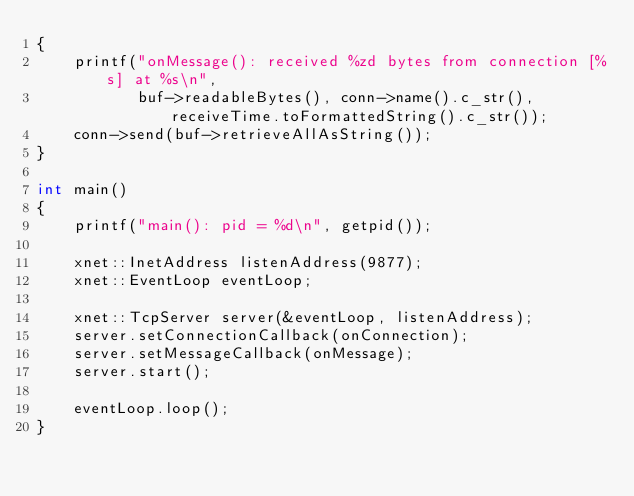Convert code to text. <code><loc_0><loc_0><loc_500><loc_500><_C++_>{
    printf("onMessage(): received %zd bytes from connection [%s] at %s\n",
           buf->readableBytes(), conn->name().c_str(), receiveTime.toFormattedString().c_str());
    conn->send(buf->retrieveAllAsString());
}

int main()
{
    printf("main(): pid = %d\n", getpid());

    xnet::InetAddress listenAddress(9877);
    xnet::EventLoop eventLoop;

    xnet::TcpServer server(&eventLoop, listenAddress);
    server.setConnectionCallback(onConnection);
    server.setMessageCallback(onMessage);
    server.start();

    eventLoop.loop();
}
</code> 